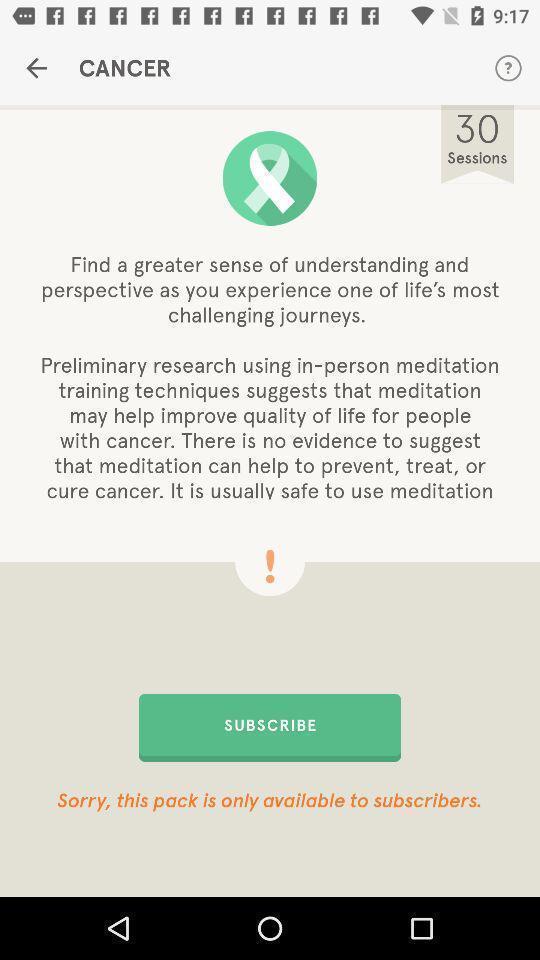Explain what's happening in this screen capture. Welcome page of a health app. 